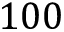Convert formula to latex. <formula><loc_0><loc_0><loc_500><loc_500>1 0 0</formula> 